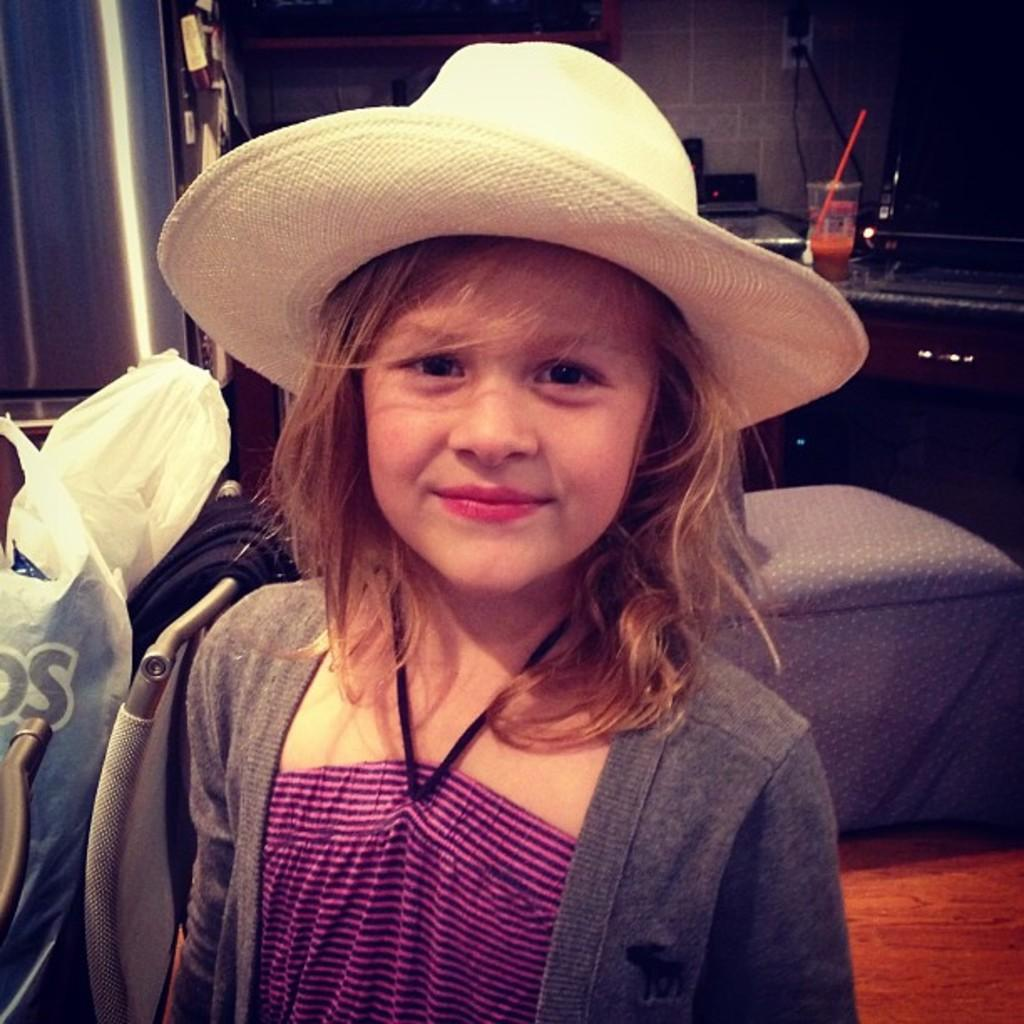What is the main subject of the image? The main subject of the image is a kid. What is the kid wearing in the image? The kid is wearing a hat in the image. What piece of furniture is present in the image? There is a desk and a chair in the image. What can be seen on the desk? There is a glass on the desk in the image. Can you describe any other objects or elements in the image? There are other unspecified things in the image. What type of insect is crawling on the kid's hat in the image? There is no insect present on the kid's hat in the image. What is the kid's opinion on office work, as depicted in the image? The image does not provide any information about the kid's opinion on office work. 